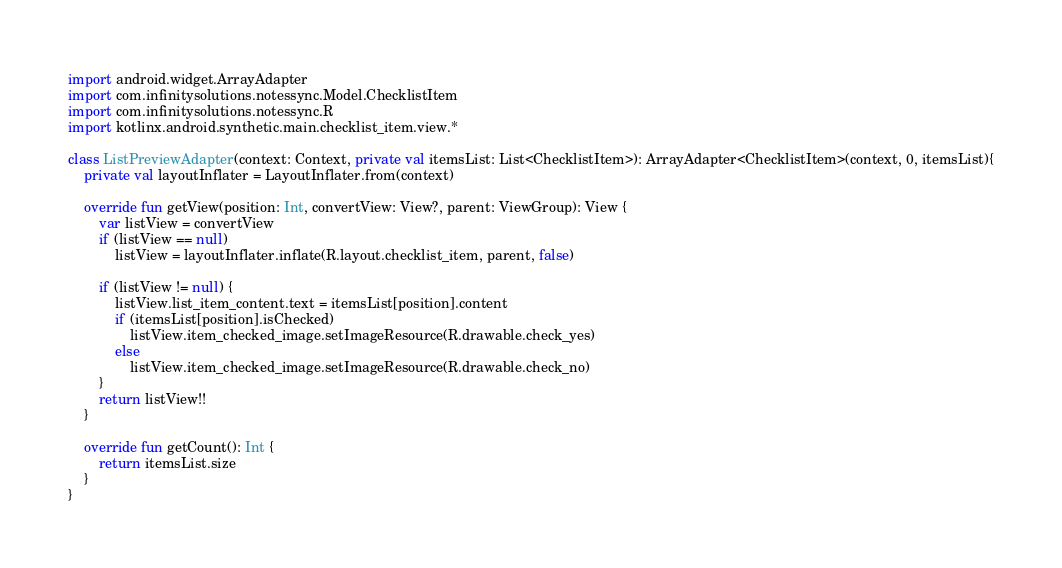<code> <loc_0><loc_0><loc_500><loc_500><_Kotlin_>import android.widget.ArrayAdapter
import com.infinitysolutions.notessync.Model.ChecklistItem
import com.infinitysolutions.notessync.R
import kotlinx.android.synthetic.main.checklist_item.view.*

class ListPreviewAdapter(context: Context, private val itemsList: List<ChecklistItem>): ArrayAdapter<ChecklistItem>(context, 0, itemsList){
    private val layoutInflater = LayoutInflater.from(context)

    override fun getView(position: Int, convertView: View?, parent: ViewGroup): View {
        var listView = convertView
        if (listView == null)
            listView = layoutInflater.inflate(R.layout.checklist_item, parent, false)

        if (listView != null) {
            listView.list_item_content.text = itemsList[position].content
            if (itemsList[position].isChecked)
                listView.item_checked_image.setImageResource(R.drawable.check_yes)
            else
                listView.item_checked_image.setImageResource(R.drawable.check_no)
        }
        return listView!!
    }

    override fun getCount(): Int {
        return itemsList.size
    }
}</code> 